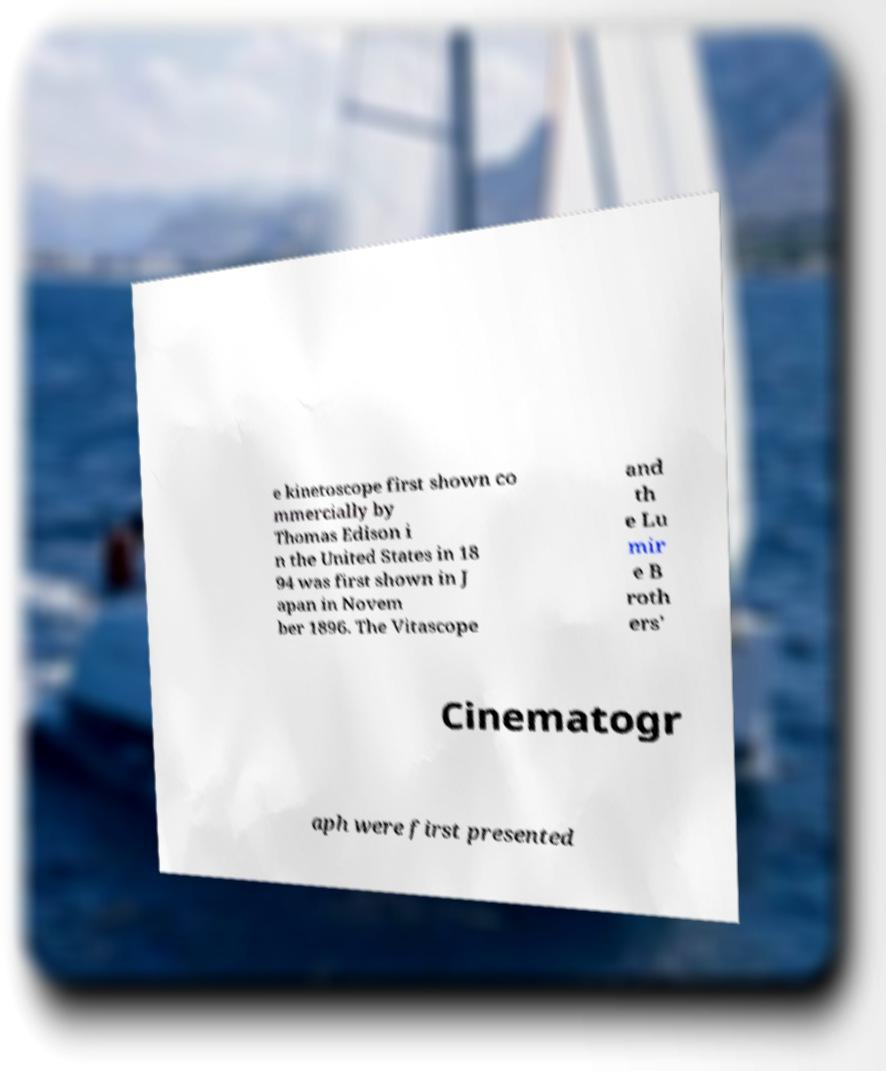Can you accurately transcribe the text from the provided image for me? e kinetoscope first shown co mmercially by Thomas Edison i n the United States in 18 94 was first shown in J apan in Novem ber 1896. The Vitascope and th e Lu mir e B roth ers' Cinematogr aph were first presented 